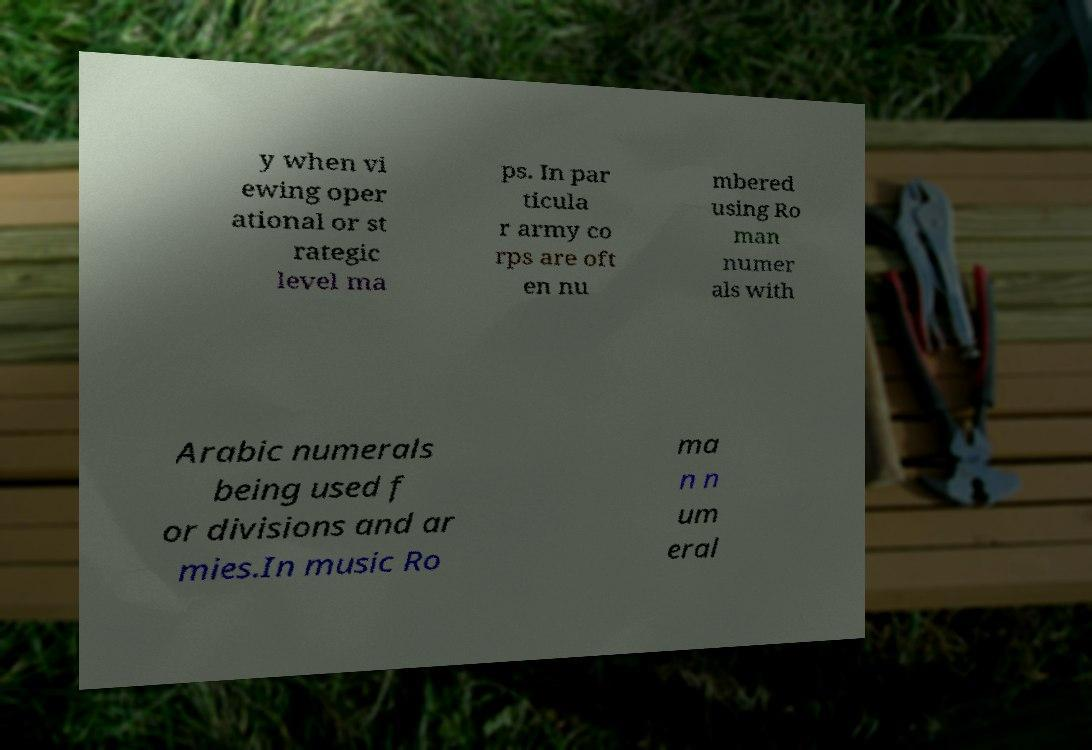Please identify and transcribe the text found in this image. y when vi ewing oper ational or st rategic level ma ps. In par ticula r army co rps are oft en nu mbered using Ro man numer als with Arabic numerals being used f or divisions and ar mies.In music Ro ma n n um eral 